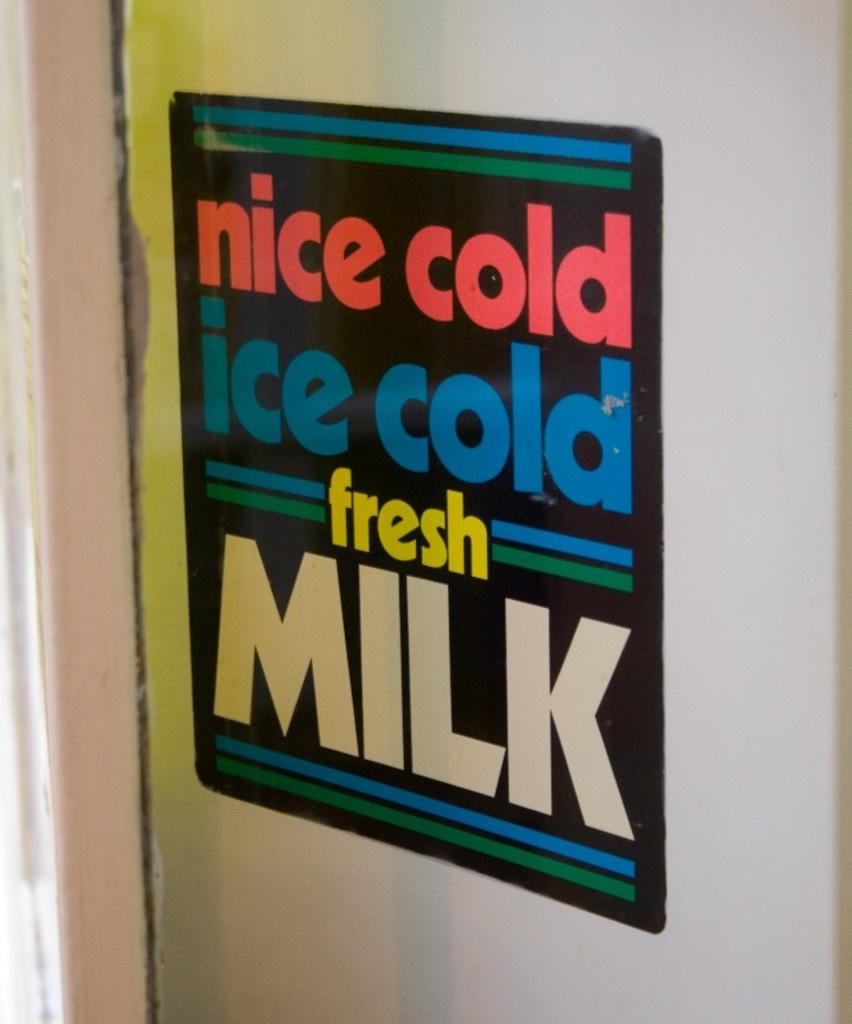<image>
Describe the image concisely. Ice cold ice cold fresh milk sign on a door 